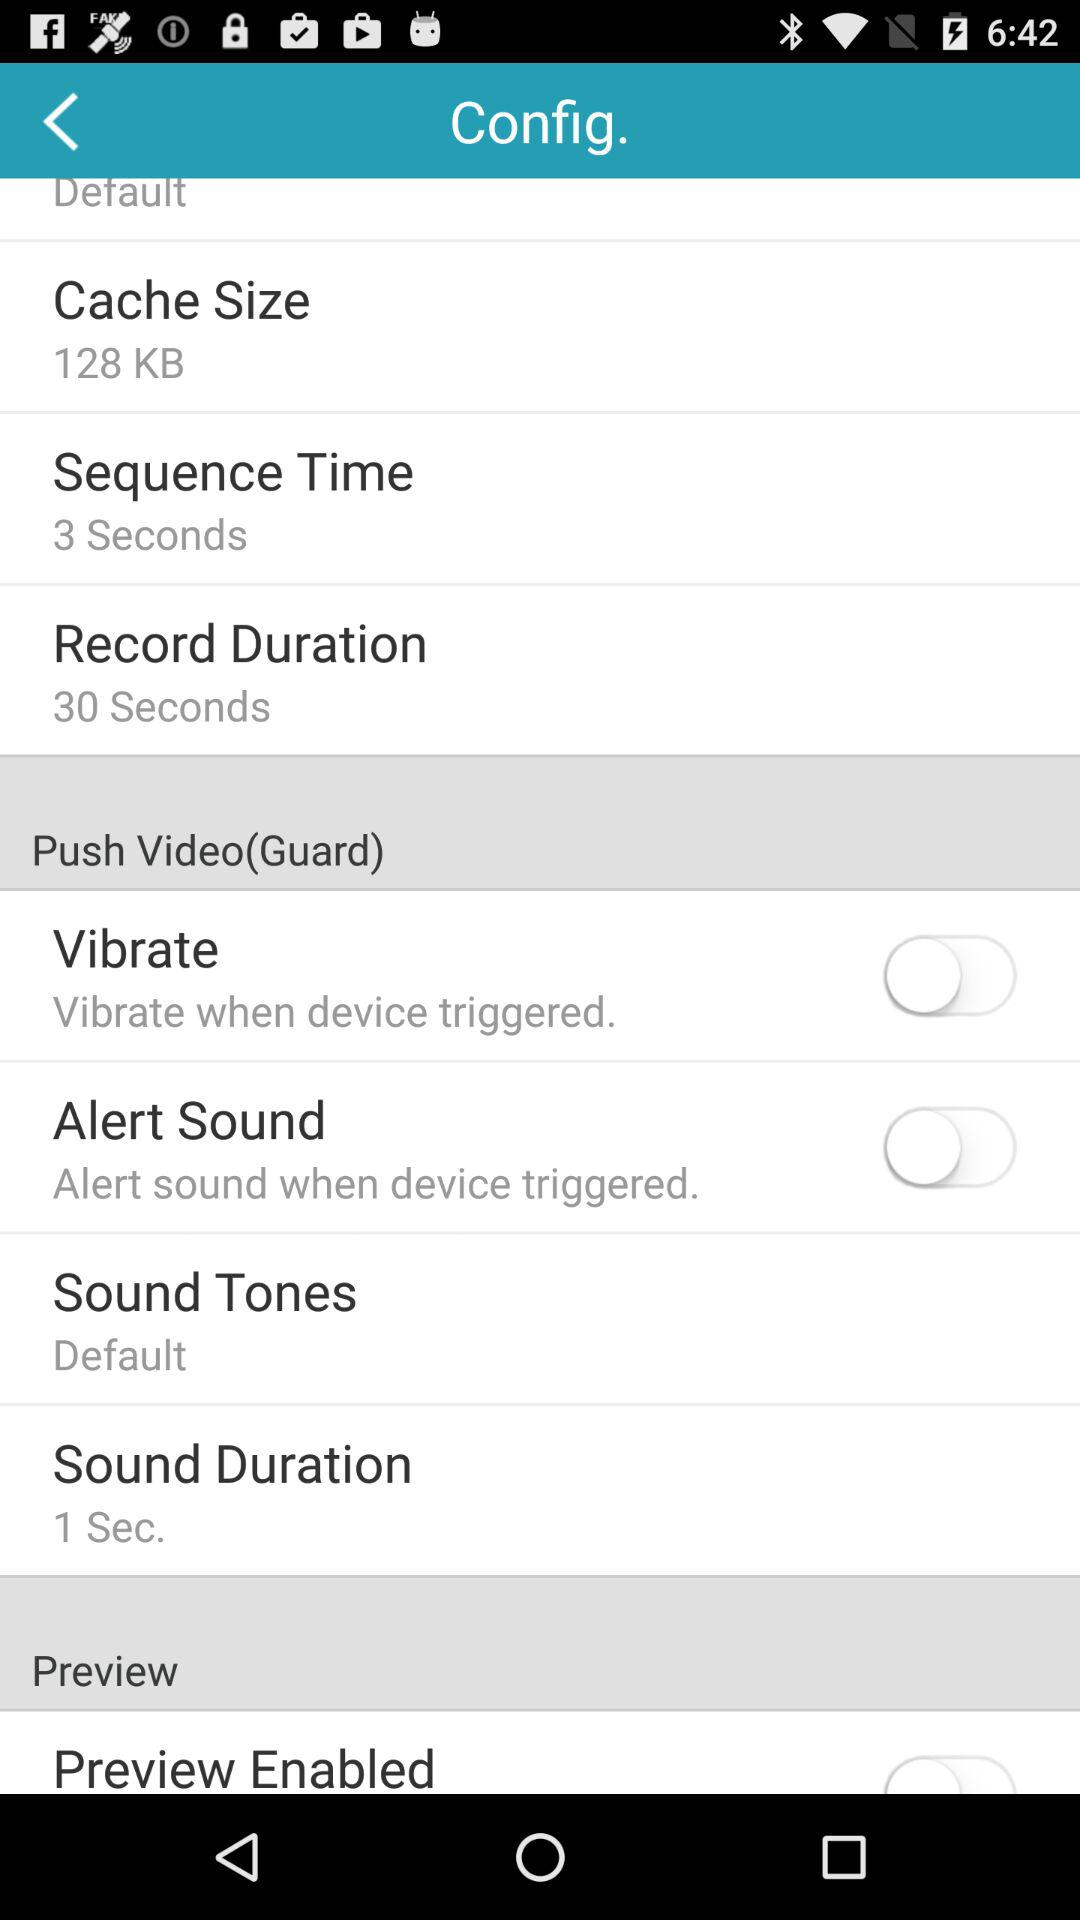What is the record time duration? The record time duration is 30 seconds. 